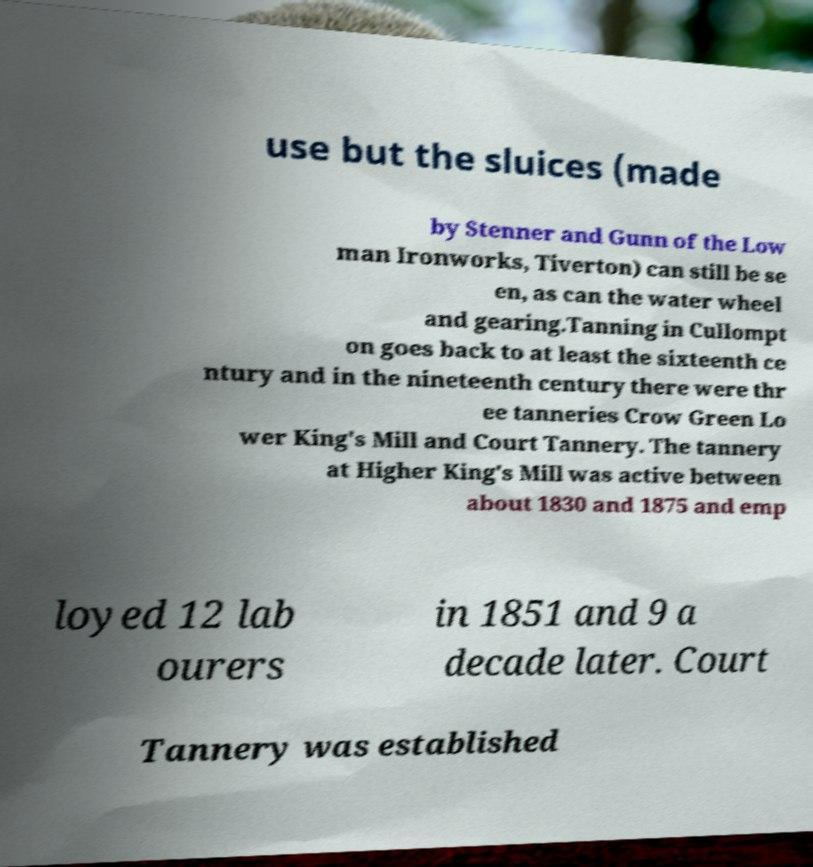Please identify and transcribe the text found in this image. use but the sluices (made by Stenner and Gunn of the Low man Ironworks, Tiverton) can still be se en, as can the water wheel and gearing.Tanning in Cullompt on goes back to at least the sixteenth ce ntury and in the nineteenth century there were thr ee tanneries Crow Green Lo wer King's Mill and Court Tannery. The tannery at Higher King's Mill was active between about 1830 and 1875 and emp loyed 12 lab ourers in 1851 and 9 a decade later. Court Tannery was established 